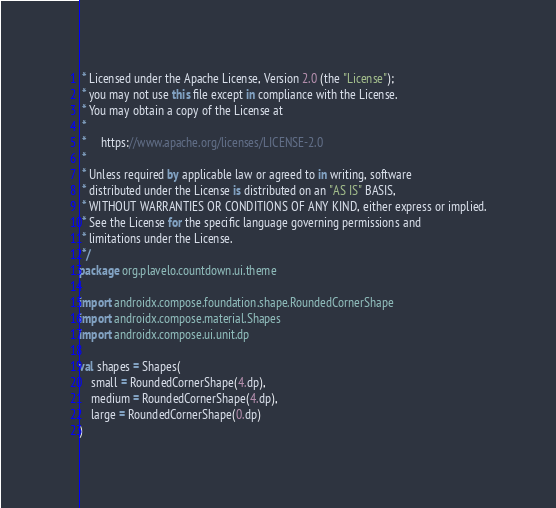Convert code to text. <code><loc_0><loc_0><loc_500><loc_500><_Kotlin_> * Licensed under the Apache License, Version 2.0 (the "License");
 * you may not use this file except in compliance with the License.
 * You may obtain a copy of the License at
 *
 *     https://www.apache.org/licenses/LICENSE-2.0
 *
 * Unless required by applicable law or agreed to in writing, software
 * distributed under the License is distributed on an "AS IS" BASIS,
 * WITHOUT WARRANTIES OR CONDITIONS OF ANY KIND, either express or implied.
 * See the License for the specific language governing permissions and
 * limitations under the License.
 */
package org.plavelo.countdown.ui.theme

import androidx.compose.foundation.shape.RoundedCornerShape
import androidx.compose.material.Shapes
import androidx.compose.ui.unit.dp

val shapes = Shapes(
    small = RoundedCornerShape(4.dp),
    medium = RoundedCornerShape(4.dp),
    large = RoundedCornerShape(0.dp)
)
</code> 